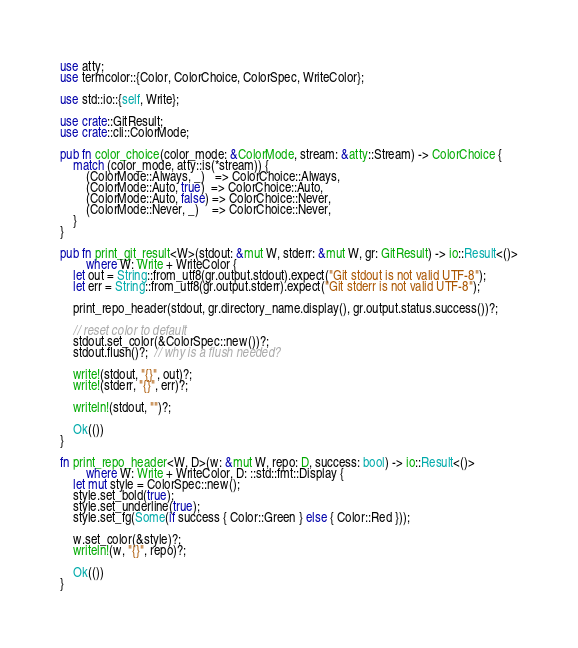<code> <loc_0><loc_0><loc_500><loc_500><_Rust_>use atty;
use termcolor::{Color, ColorChoice, ColorSpec, WriteColor};

use std::io::{self, Write};

use crate::GitResult;
use crate::cli::ColorMode;

pub fn color_choice(color_mode: &ColorMode, stream: &atty::Stream) -> ColorChoice {
    match (color_mode, atty::is(*stream)) {
        (ColorMode::Always, _)   => ColorChoice::Always,
        (ColorMode::Auto, true)  => ColorChoice::Auto,
        (ColorMode::Auto, false) => ColorChoice::Never,
        (ColorMode::Never, _)    => ColorChoice::Never,
    }
}

pub fn print_git_result<W>(stdout: &mut W, stderr: &mut W, gr: GitResult) -> io::Result<()>
        where W: Write + WriteColor {
    let out = String::from_utf8(gr.output.stdout).expect("Git stdout is not valid UTF-8");
    let err = String::from_utf8(gr.output.stderr).expect("Git stderr is not valid UTF-8");

    print_repo_header(stdout, gr.directory_name.display(), gr.output.status.success())?;

    // reset color to default
    stdout.set_color(&ColorSpec::new())?;
    stdout.flush()?;  // why is a flush needed?

    write!(stdout, "{}", out)?;
    write!(stderr, "{}", err)?;

    writeln!(stdout, "")?;

    Ok(())
}

fn print_repo_header<W, D>(w: &mut W, repo: D, success: bool) -> io::Result<()>
        where W: Write + WriteColor, D: ::std::fmt::Display {
    let mut style = ColorSpec::new();
    style.set_bold(true);
    style.set_underline(true);
    style.set_fg(Some(if success { Color::Green } else { Color::Red }));

    w.set_color(&style)?;
    writeln!(w, "{}", repo)?;

    Ok(())
}
</code> 